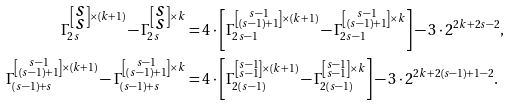<formula> <loc_0><loc_0><loc_500><loc_500>\Gamma _ { 2 s } ^ { \left [ \substack { s \\ s } \right ] \times ( k + 1 ) } - \Gamma _ { 2 s } ^ { \left [ \substack { s \\ s } \right ] \times k } & = 4 \cdot \left [ \Gamma _ { 2 s - 1 } ^ { \left [ \substack { s - 1 \\ ( s - 1 ) + 1 } \right ] \times ( k + 1 ) } - \Gamma _ { 2 s - 1 } ^ { \left [ \substack { s - 1 \\ ( s - 1 ) + 1 } \right ] \times k } \right ] - 3 \cdot 2 ^ { 2 k + 2 s - 2 } , \\ \Gamma _ { ( s - 1 ) + s } ^ { \left [ \substack { s - 1 \\ ( s - 1 ) + 1 } \right ] \times ( k + 1 ) } - \Gamma _ { ( s - 1 ) + s } ^ { \left [ \substack { s - 1 \\ ( s - 1 ) + 1 } \right ] \times k } & = 4 \cdot \left [ \Gamma _ { 2 ( s - 1 ) } ^ { \left [ \substack { s - 1 \\ s - 1 } \right ] \times ( k + 1 ) } - \Gamma _ { 2 ( s - 1 ) } ^ { \left [ \substack { s - 1 \\ s - 1 } \right ] \times k } \right ] - 3 \cdot 2 ^ { 2 k + 2 ( s - 1 ) + 1 - 2 } . \\</formula> 